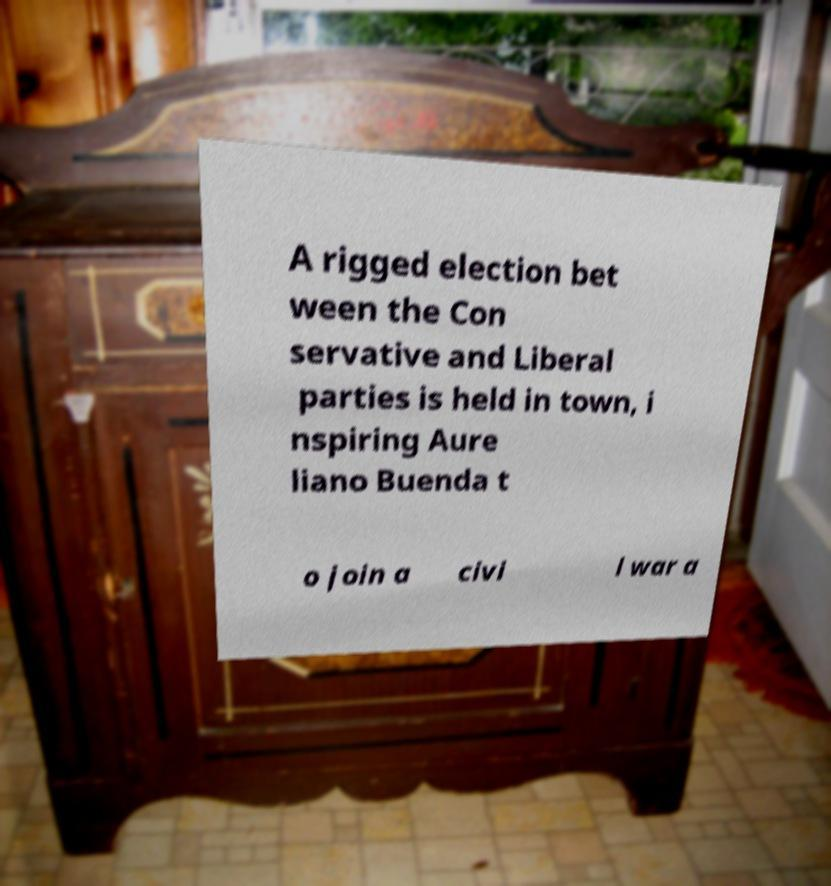Can you read and provide the text displayed in the image?This photo seems to have some interesting text. Can you extract and type it out for me? A rigged election bet ween the Con servative and Liberal parties is held in town, i nspiring Aure liano Buenda t o join a civi l war a 